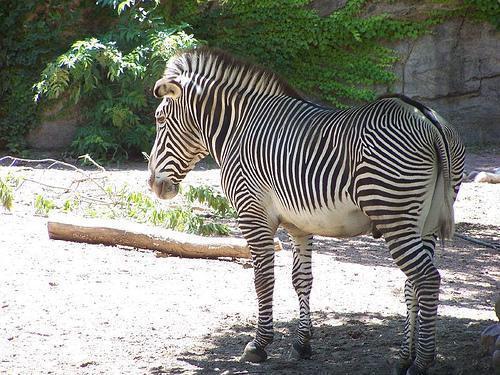How many beds are there?
Give a very brief answer. 0. 